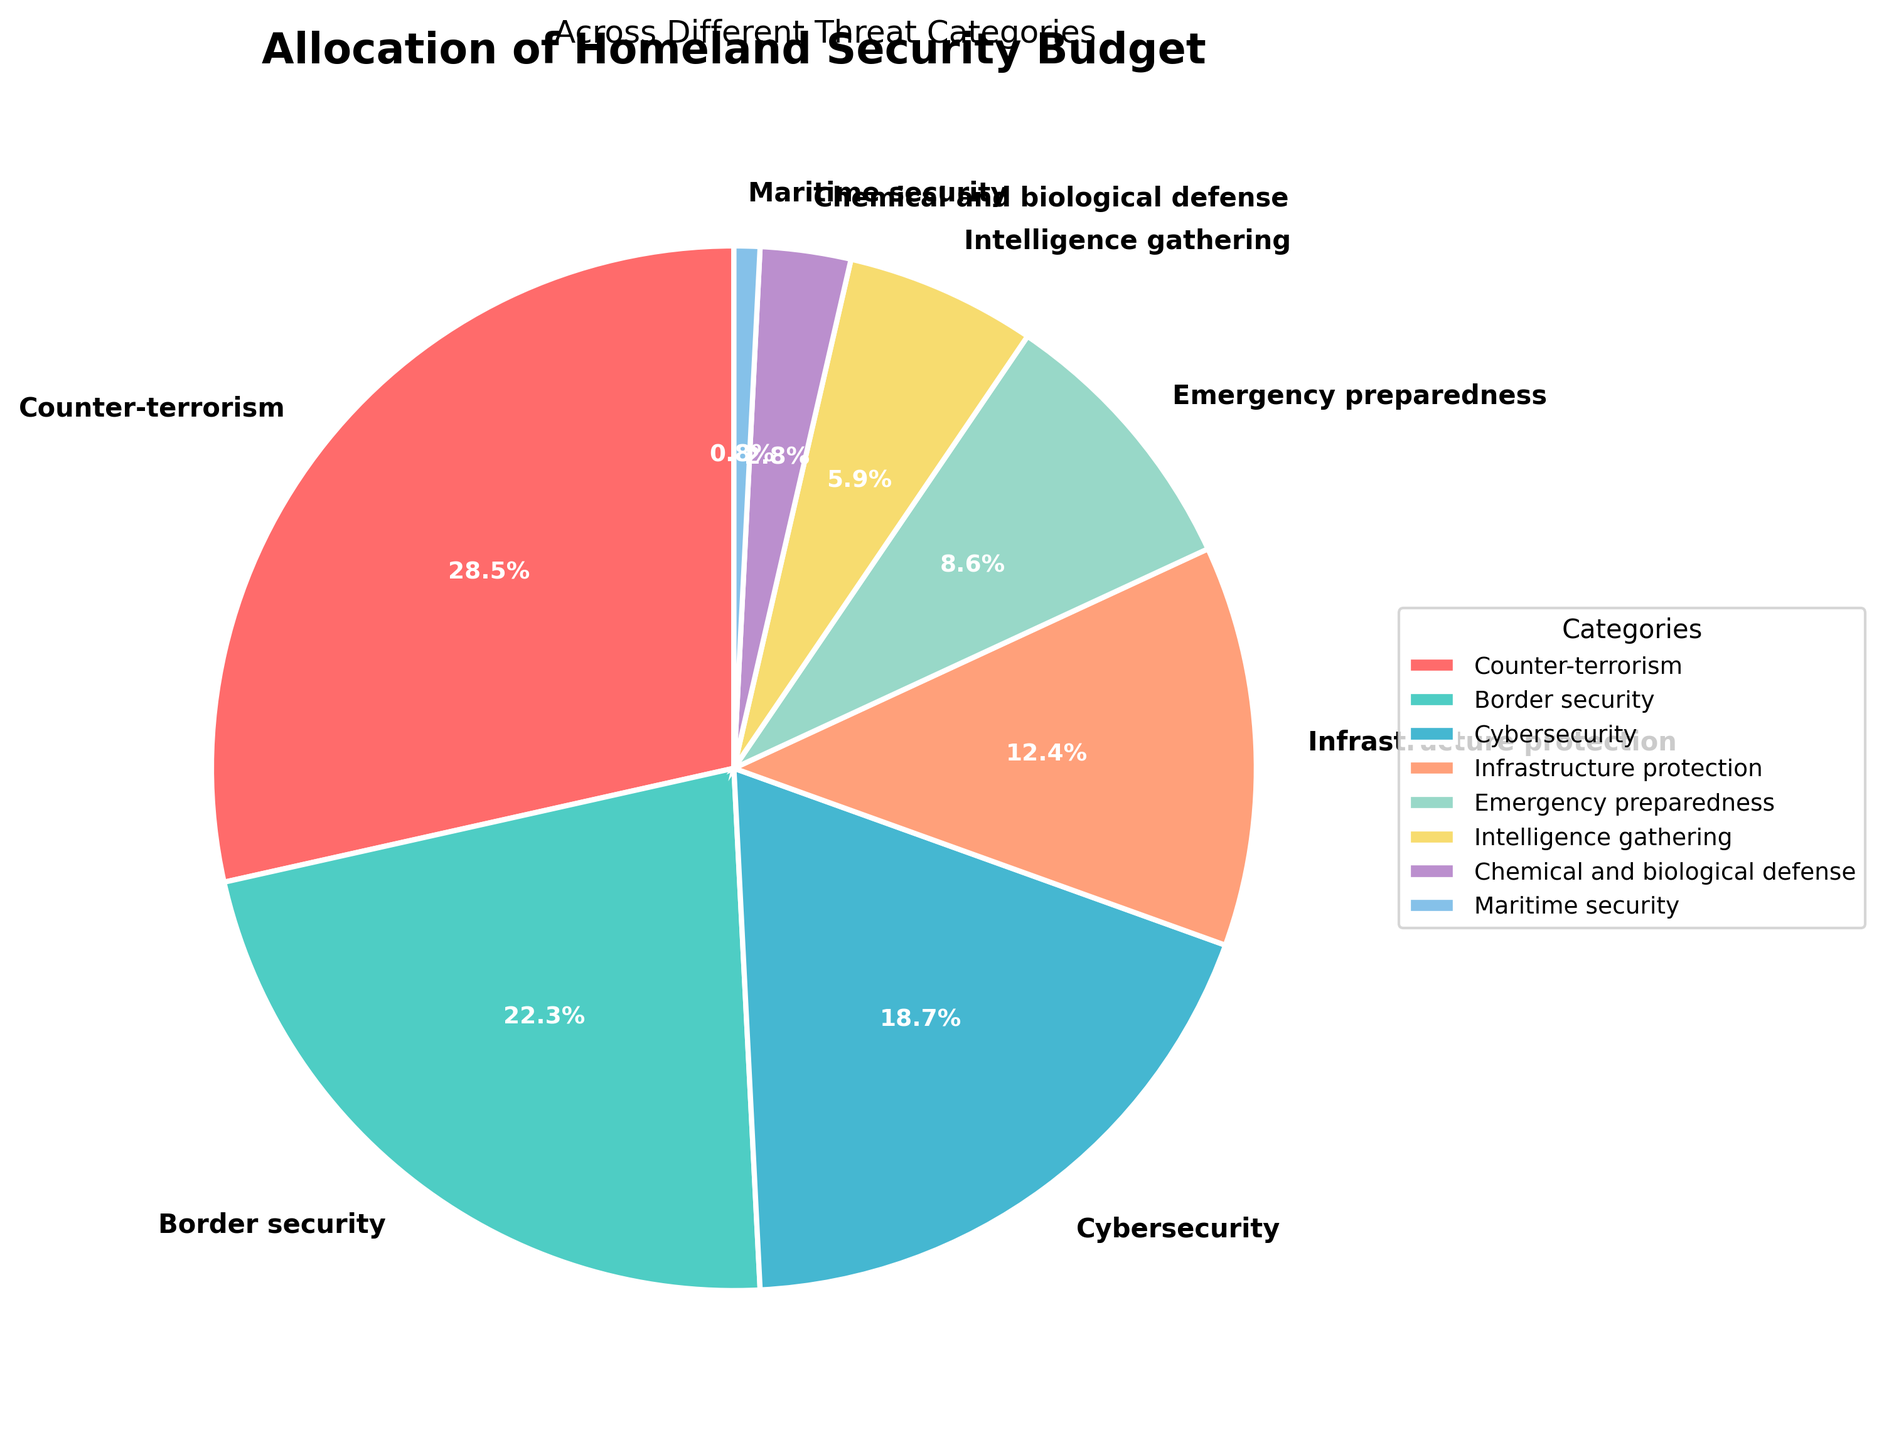Which category receives the largest portion of the homeland security budget? To determine the category with the largest portion, look at the pie segments and their associated labels. The category "Counter-terrorism" has the largest percentage of 28.5%.
Answer: Counter-terrorism How much larger is the budget allocation for counter-terrorism compared to cybersecurity? Compare the percentages for counter-terrorism (28.5%) and cybersecurity (18.7%). Subtract the smaller percentage from the larger one: 28.5% - 18.7% = 9.8%.
Answer: 9.8% Which two categories combined make up approximately one-third of the total budget? To find two categories that sum to about one-third (approximately 33.3%), look at the pairs of percentages. "Border security" (22.3%) and "Emergency preparedness" (8.6%) combined give 22.3% + 8.6% = 30.9%, which is close to one-third.
Answer: Border security and Emergency preparedness What is the difference between the allocations for border security and intelligence gathering? Subtract the percentage for intelligence gathering (5.9%) from the percentage for border security (22.3%): 22.3% - 5.9% = 16.4%.
Answer: 16.4% What percentage of the budget is allocated to categories other than counter-terrorism and border security? Sum the percentages for counter-terrorism (28.5%) and border security (22.3%): 28.5% + 22.3% = 50.8%. Subtract this from 100%: 100% - 50.8% = 49.2%.
Answer: 49.2% Which category has the smallest budget allocation and what is its percentage? To find the smallest allocation, look at the labels and percentages around the pie chart. "Maritime security" has the smallest percentage of 0.8%.
Answer: Maritime security, 0.8% How does the allocation for infrastructure protection compare to that for cybersecurity? Compare the percentages for infrastructure protection (12.4%) and cybersecurity (18.7%). Since 18.7% is greater than 12.4%, cybersecurity has a larger allocation.
Answer: Cybersecurity has a larger allocation Which categories have an allocation of less than 10%? Look at the pie chart and find categories with percentages below 10%. These are "Emergency preparedness" (8.6%), "Intelligence gathering" (5.9%), "Chemical and biological defense" (2.8%), and "Maritime security" (0.8%).
Answer: Emergency preparedness, Intelligence gathering, Chemical and biological defense, Maritime security What is the total percentage allocated to intelligence gathering and chemical and biological defense combined? Add the percentages for intelligence gathering (5.9%) and chemical and biological defense (2.8%): 5.9% + 2.8% = 8.7%.
Answer: 8.7% If we needed to cut 1% from cyber security and allocate it to maritime security, what would the new allocations be for these two categories? Subtract 1% from cybersecurity (18.7% - 1% = 17.7%) and add it to maritime security (0.8% + 1% = 1.8%).
Answer: Cybersecurity: 17.7%, Maritime security: 1.8% 